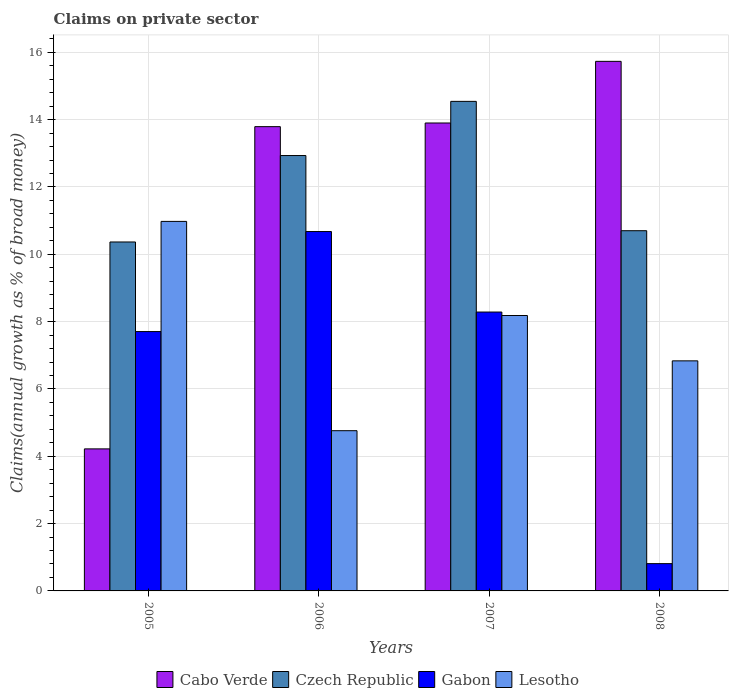How many bars are there on the 3rd tick from the left?
Offer a very short reply. 4. What is the label of the 3rd group of bars from the left?
Give a very brief answer. 2007. What is the percentage of broad money claimed on private sector in Czech Republic in 2008?
Offer a terse response. 10.7. Across all years, what is the maximum percentage of broad money claimed on private sector in Lesotho?
Keep it short and to the point. 10.98. Across all years, what is the minimum percentage of broad money claimed on private sector in Lesotho?
Ensure brevity in your answer.  4.76. What is the total percentage of broad money claimed on private sector in Cabo Verde in the graph?
Your answer should be compact. 47.64. What is the difference between the percentage of broad money claimed on private sector in Gabon in 2006 and that in 2007?
Provide a succinct answer. 2.39. What is the difference between the percentage of broad money claimed on private sector in Gabon in 2008 and the percentage of broad money claimed on private sector in Cabo Verde in 2006?
Your answer should be compact. -12.98. What is the average percentage of broad money claimed on private sector in Lesotho per year?
Offer a very short reply. 7.69. In the year 2005, what is the difference between the percentage of broad money claimed on private sector in Cabo Verde and percentage of broad money claimed on private sector in Lesotho?
Ensure brevity in your answer.  -6.76. What is the ratio of the percentage of broad money claimed on private sector in Czech Republic in 2005 to that in 2008?
Provide a short and direct response. 0.97. Is the percentage of broad money claimed on private sector in Czech Republic in 2005 less than that in 2007?
Your answer should be compact. Yes. What is the difference between the highest and the second highest percentage of broad money claimed on private sector in Cabo Verde?
Make the answer very short. 1.83. What is the difference between the highest and the lowest percentage of broad money claimed on private sector in Cabo Verde?
Make the answer very short. 11.51. In how many years, is the percentage of broad money claimed on private sector in Lesotho greater than the average percentage of broad money claimed on private sector in Lesotho taken over all years?
Give a very brief answer. 2. Is it the case that in every year, the sum of the percentage of broad money claimed on private sector in Czech Republic and percentage of broad money claimed on private sector in Cabo Verde is greater than the sum of percentage of broad money claimed on private sector in Gabon and percentage of broad money claimed on private sector in Lesotho?
Offer a terse response. Yes. What does the 4th bar from the left in 2005 represents?
Offer a terse response. Lesotho. What does the 2nd bar from the right in 2005 represents?
Keep it short and to the point. Gabon. How many years are there in the graph?
Your answer should be compact. 4. Does the graph contain any zero values?
Offer a terse response. No. What is the title of the graph?
Your answer should be compact. Claims on private sector. Does "Libya" appear as one of the legend labels in the graph?
Provide a succinct answer. No. What is the label or title of the Y-axis?
Your response must be concise. Claims(annual growth as % of broad money). What is the Claims(annual growth as % of broad money) in Cabo Verde in 2005?
Keep it short and to the point. 4.22. What is the Claims(annual growth as % of broad money) in Czech Republic in 2005?
Ensure brevity in your answer.  10.37. What is the Claims(annual growth as % of broad money) of Gabon in 2005?
Your answer should be compact. 7.7. What is the Claims(annual growth as % of broad money) in Lesotho in 2005?
Ensure brevity in your answer.  10.98. What is the Claims(annual growth as % of broad money) in Cabo Verde in 2006?
Offer a terse response. 13.79. What is the Claims(annual growth as % of broad money) of Czech Republic in 2006?
Your answer should be very brief. 12.93. What is the Claims(annual growth as % of broad money) in Gabon in 2006?
Ensure brevity in your answer.  10.68. What is the Claims(annual growth as % of broad money) in Lesotho in 2006?
Provide a succinct answer. 4.76. What is the Claims(annual growth as % of broad money) of Cabo Verde in 2007?
Give a very brief answer. 13.9. What is the Claims(annual growth as % of broad money) in Czech Republic in 2007?
Provide a short and direct response. 14.54. What is the Claims(annual growth as % of broad money) in Gabon in 2007?
Offer a terse response. 8.28. What is the Claims(annual growth as % of broad money) in Lesotho in 2007?
Your response must be concise. 8.18. What is the Claims(annual growth as % of broad money) of Cabo Verde in 2008?
Make the answer very short. 15.73. What is the Claims(annual growth as % of broad money) of Czech Republic in 2008?
Make the answer very short. 10.7. What is the Claims(annual growth as % of broad money) of Gabon in 2008?
Offer a very short reply. 0.81. What is the Claims(annual growth as % of broad money) in Lesotho in 2008?
Provide a short and direct response. 6.83. Across all years, what is the maximum Claims(annual growth as % of broad money) in Cabo Verde?
Provide a succinct answer. 15.73. Across all years, what is the maximum Claims(annual growth as % of broad money) of Czech Republic?
Make the answer very short. 14.54. Across all years, what is the maximum Claims(annual growth as % of broad money) of Gabon?
Make the answer very short. 10.68. Across all years, what is the maximum Claims(annual growth as % of broad money) of Lesotho?
Your response must be concise. 10.98. Across all years, what is the minimum Claims(annual growth as % of broad money) in Cabo Verde?
Provide a short and direct response. 4.22. Across all years, what is the minimum Claims(annual growth as % of broad money) of Czech Republic?
Give a very brief answer. 10.37. Across all years, what is the minimum Claims(annual growth as % of broad money) in Gabon?
Ensure brevity in your answer.  0.81. Across all years, what is the minimum Claims(annual growth as % of broad money) of Lesotho?
Provide a succinct answer. 4.76. What is the total Claims(annual growth as % of broad money) in Cabo Verde in the graph?
Your response must be concise. 47.64. What is the total Claims(annual growth as % of broad money) of Czech Republic in the graph?
Offer a terse response. 48.54. What is the total Claims(annual growth as % of broad money) in Gabon in the graph?
Provide a short and direct response. 27.47. What is the total Claims(annual growth as % of broad money) in Lesotho in the graph?
Make the answer very short. 30.75. What is the difference between the Claims(annual growth as % of broad money) of Cabo Verde in 2005 and that in 2006?
Offer a very short reply. -9.57. What is the difference between the Claims(annual growth as % of broad money) in Czech Republic in 2005 and that in 2006?
Give a very brief answer. -2.57. What is the difference between the Claims(annual growth as % of broad money) of Gabon in 2005 and that in 2006?
Give a very brief answer. -2.97. What is the difference between the Claims(annual growth as % of broad money) in Lesotho in 2005 and that in 2006?
Make the answer very short. 6.22. What is the difference between the Claims(annual growth as % of broad money) in Cabo Verde in 2005 and that in 2007?
Your response must be concise. -9.68. What is the difference between the Claims(annual growth as % of broad money) of Czech Republic in 2005 and that in 2007?
Give a very brief answer. -4.18. What is the difference between the Claims(annual growth as % of broad money) of Gabon in 2005 and that in 2007?
Your answer should be very brief. -0.58. What is the difference between the Claims(annual growth as % of broad money) in Lesotho in 2005 and that in 2007?
Your answer should be compact. 2.8. What is the difference between the Claims(annual growth as % of broad money) of Cabo Verde in 2005 and that in 2008?
Make the answer very short. -11.51. What is the difference between the Claims(annual growth as % of broad money) in Czech Republic in 2005 and that in 2008?
Provide a short and direct response. -0.33. What is the difference between the Claims(annual growth as % of broad money) in Gabon in 2005 and that in 2008?
Provide a succinct answer. 6.89. What is the difference between the Claims(annual growth as % of broad money) in Lesotho in 2005 and that in 2008?
Your response must be concise. 4.14. What is the difference between the Claims(annual growth as % of broad money) of Cabo Verde in 2006 and that in 2007?
Provide a succinct answer. -0.11. What is the difference between the Claims(annual growth as % of broad money) of Czech Republic in 2006 and that in 2007?
Your answer should be very brief. -1.61. What is the difference between the Claims(annual growth as % of broad money) in Gabon in 2006 and that in 2007?
Give a very brief answer. 2.39. What is the difference between the Claims(annual growth as % of broad money) of Lesotho in 2006 and that in 2007?
Provide a short and direct response. -3.42. What is the difference between the Claims(annual growth as % of broad money) in Cabo Verde in 2006 and that in 2008?
Make the answer very short. -1.94. What is the difference between the Claims(annual growth as % of broad money) in Czech Republic in 2006 and that in 2008?
Your answer should be compact. 2.23. What is the difference between the Claims(annual growth as % of broad money) of Gabon in 2006 and that in 2008?
Your answer should be compact. 9.86. What is the difference between the Claims(annual growth as % of broad money) of Lesotho in 2006 and that in 2008?
Your response must be concise. -2.07. What is the difference between the Claims(annual growth as % of broad money) of Cabo Verde in 2007 and that in 2008?
Keep it short and to the point. -1.83. What is the difference between the Claims(annual growth as % of broad money) of Czech Republic in 2007 and that in 2008?
Your answer should be compact. 3.84. What is the difference between the Claims(annual growth as % of broad money) of Gabon in 2007 and that in 2008?
Ensure brevity in your answer.  7.47. What is the difference between the Claims(annual growth as % of broad money) in Lesotho in 2007 and that in 2008?
Ensure brevity in your answer.  1.35. What is the difference between the Claims(annual growth as % of broad money) of Cabo Verde in 2005 and the Claims(annual growth as % of broad money) of Czech Republic in 2006?
Provide a short and direct response. -8.71. What is the difference between the Claims(annual growth as % of broad money) of Cabo Verde in 2005 and the Claims(annual growth as % of broad money) of Gabon in 2006?
Offer a very short reply. -6.46. What is the difference between the Claims(annual growth as % of broad money) of Cabo Verde in 2005 and the Claims(annual growth as % of broad money) of Lesotho in 2006?
Offer a very short reply. -0.54. What is the difference between the Claims(annual growth as % of broad money) of Czech Republic in 2005 and the Claims(annual growth as % of broad money) of Gabon in 2006?
Provide a succinct answer. -0.31. What is the difference between the Claims(annual growth as % of broad money) in Czech Republic in 2005 and the Claims(annual growth as % of broad money) in Lesotho in 2006?
Keep it short and to the point. 5.61. What is the difference between the Claims(annual growth as % of broad money) in Gabon in 2005 and the Claims(annual growth as % of broad money) in Lesotho in 2006?
Keep it short and to the point. 2.94. What is the difference between the Claims(annual growth as % of broad money) in Cabo Verde in 2005 and the Claims(annual growth as % of broad money) in Czech Republic in 2007?
Make the answer very short. -10.32. What is the difference between the Claims(annual growth as % of broad money) of Cabo Verde in 2005 and the Claims(annual growth as % of broad money) of Gabon in 2007?
Your answer should be very brief. -4.06. What is the difference between the Claims(annual growth as % of broad money) in Cabo Verde in 2005 and the Claims(annual growth as % of broad money) in Lesotho in 2007?
Your answer should be compact. -3.96. What is the difference between the Claims(annual growth as % of broad money) of Czech Republic in 2005 and the Claims(annual growth as % of broad money) of Gabon in 2007?
Ensure brevity in your answer.  2.08. What is the difference between the Claims(annual growth as % of broad money) in Czech Republic in 2005 and the Claims(annual growth as % of broad money) in Lesotho in 2007?
Ensure brevity in your answer.  2.18. What is the difference between the Claims(annual growth as % of broad money) in Gabon in 2005 and the Claims(annual growth as % of broad money) in Lesotho in 2007?
Offer a very short reply. -0.48. What is the difference between the Claims(annual growth as % of broad money) in Cabo Verde in 2005 and the Claims(annual growth as % of broad money) in Czech Republic in 2008?
Your answer should be very brief. -6.48. What is the difference between the Claims(annual growth as % of broad money) of Cabo Verde in 2005 and the Claims(annual growth as % of broad money) of Gabon in 2008?
Give a very brief answer. 3.41. What is the difference between the Claims(annual growth as % of broad money) of Cabo Verde in 2005 and the Claims(annual growth as % of broad money) of Lesotho in 2008?
Your response must be concise. -2.61. What is the difference between the Claims(annual growth as % of broad money) of Czech Republic in 2005 and the Claims(annual growth as % of broad money) of Gabon in 2008?
Ensure brevity in your answer.  9.55. What is the difference between the Claims(annual growth as % of broad money) of Czech Republic in 2005 and the Claims(annual growth as % of broad money) of Lesotho in 2008?
Offer a terse response. 3.53. What is the difference between the Claims(annual growth as % of broad money) of Gabon in 2005 and the Claims(annual growth as % of broad money) of Lesotho in 2008?
Offer a very short reply. 0.87. What is the difference between the Claims(annual growth as % of broad money) of Cabo Verde in 2006 and the Claims(annual growth as % of broad money) of Czech Republic in 2007?
Offer a terse response. -0.75. What is the difference between the Claims(annual growth as % of broad money) in Cabo Verde in 2006 and the Claims(annual growth as % of broad money) in Gabon in 2007?
Provide a succinct answer. 5.51. What is the difference between the Claims(annual growth as % of broad money) of Cabo Verde in 2006 and the Claims(annual growth as % of broad money) of Lesotho in 2007?
Keep it short and to the point. 5.61. What is the difference between the Claims(annual growth as % of broad money) of Czech Republic in 2006 and the Claims(annual growth as % of broad money) of Gabon in 2007?
Your response must be concise. 4.65. What is the difference between the Claims(annual growth as % of broad money) of Czech Republic in 2006 and the Claims(annual growth as % of broad money) of Lesotho in 2007?
Your answer should be compact. 4.75. What is the difference between the Claims(annual growth as % of broad money) of Gabon in 2006 and the Claims(annual growth as % of broad money) of Lesotho in 2007?
Provide a succinct answer. 2.49. What is the difference between the Claims(annual growth as % of broad money) of Cabo Verde in 2006 and the Claims(annual growth as % of broad money) of Czech Republic in 2008?
Your answer should be very brief. 3.09. What is the difference between the Claims(annual growth as % of broad money) of Cabo Verde in 2006 and the Claims(annual growth as % of broad money) of Gabon in 2008?
Your answer should be compact. 12.98. What is the difference between the Claims(annual growth as % of broad money) of Cabo Verde in 2006 and the Claims(annual growth as % of broad money) of Lesotho in 2008?
Your answer should be compact. 6.96. What is the difference between the Claims(annual growth as % of broad money) of Czech Republic in 2006 and the Claims(annual growth as % of broad money) of Gabon in 2008?
Your response must be concise. 12.12. What is the difference between the Claims(annual growth as % of broad money) in Czech Republic in 2006 and the Claims(annual growth as % of broad money) in Lesotho in 2008?
Your answer should be very brief. 6.1. What is the difference between the Claims(annual growth as % of broad money) in Gabon in 2006 and the Claims(annual growth as % of broad money) in Lesotho in 2008?
Make the answer very short. 3.84. What is the difference between the Claims(annual growth as % of broad money) of Cabo Verde in 2007 and the Claims(annual growth as % of broad money) of Czech Republic in 2008?
Your answer should be compact. 3.2. What is the difference between the Claims(annual growth as % of broad money) in Cabo Verde in 2007 and the Claims(annual growth as % of broad money) in Gabon in 2008?
Your response must be concise. 13.09. What is the difference between the Claims(annual growth as % of broad money) in Cabo Verde in 2007 and the Claims(annual growth as % of broad money) in Lesotho in 2008?
Offer a very short reply. 7.07. What is the difference between the Claims(annual growth as % of broad money) of Czech Republic in 2007 and the Claims(annual growth as % of broad money) of Gabon in 2008?
Your answer should be compact. 13.73. What is the difference between the Claims(annual growth as % of broad money) of Czech Republic in 2007 and the Claims(annual growth as % of broad money) of Lesotho in 2008?
Your response must be concise. 7.71. What is the difference between the Claims(annual growth as % of broad money) of Gabon in 2007 and the Claims(annual growth as % of broad money) of Lesotho in 2008?
Your answer should be compact. 1.45. What is the average Claims(annual growth as % of broad money) in Cabo Verde per year?
Make the answer very short. 11.91. What is the average Claims(annual growth as % of broad money) in Czech Republic per year?
Give a very brief answer. 12.14. What is the average Claims(annual growth as % of broad money) of Gabon per year?
Your answer should be very brief. 6.87. What is the average Claims(annual growth as % of broad money) of Lesotho per year?
Offer a terse response. 7.69. In the year 2005, what is the difference between the Claims(annual growth as % of broad money) in Cabo Verde and Claims(annual growth as % of broad money) in Czech Republic?
Your answer should be compact. -6.15. In the year 2005, what is the difference between the Claims(annual growth as % of broad money) in Cabo Verde and Claims(annual growth as % of broad money) in Gabon?
Make the answer very short. -3.48. In the year 2005, what is the difference between the Claims(annual growth as % of broad money) in Cabo Verde and Claims(annual growth as % of broad money) in Lesotho?
Your response must be concise. -6.76. In the year 2005, what is the difference between the Claims(annual growth as % of broad money) in Czech Republic and Claims(annual growth as % of broad money) in Gabon?
Ensure brevity in your answer.  2.66. In the year 2005, what is the difference between the Claims(annual growth as % of broad money) in Czech Republic and Claims(annual growth as % of broad money) in Lesotho?
Provide a succinct answer. -0.61. In the year 2005, what is the difference between the Claims(annual growth as % of broad money) in Gabon and Claims(annual growth as % of broad money) in Lesotho?
Your answer should be very brief. -3.27. In the year 2006, what is the difference between the Claims(annual growth as % of broad money) of Cabo Verde and Claims(annual growth as % of broad money) of Czech Republic?
Keep it short and to the point. 0.86. In the year 2006, what is the difference between the Claims(annual growth as % of broad money) of Cabo Verde and Claims(annual growth as % of broad money) of Gabon?
Offer a very short reply. 3.12. In the year 2006, what is the difference between the Claims(annual growth as % of broad money) in Cabo Verde and Claims(annual growth as % of broad money) in Lesotho?
Make the answer very short. 9.03. In the year 2006, what is the difference between the Claims(annual growth as % of broad money) in Czech Republic and Claims(annual growth as % of broad money) in Gabon?
Your answer should be very brief. 2.26. In the year 2006, what is the difference between the Claims(annual growth as % of broad money) in Czech Republic and Claims(annual growth as % of broad money) in Lesotho?
Offer a very short reply. 8.17. In the year 2006, what is the difference between the Claims(annual growth as % of broad money) in Gabon and Claims(annual growth as % of broad money) in Lesotho?
Your answer should be compact. 5.92. In the year 2007, what is the difference between the Claims(annual growth as % of broad money) in Cabo Verde and Claims(annual growth as % of broad money) in Czech Republic?
Give a very brief answer. -0.64. In the year 2007, what is the difference between the Claims(annual growth as % of broad money) in Cabo Verde and Claims(annual growth as % of broad money) in Gabon?
Keep it short and to the point. 5.62. In the year 2007, what is the difference between the Claims(annual growth as % of broad money) in Cabo Verde and Claims(annual growth as % of broad money) in Lesotho?
Ensure brevity in your answer.  5.72. In the year 2007, what is the difference between the Claims(annual growth as % of broad money) in Czech Republic and Claims(annual growth as % of broad money) in Gabon?
Provide a short and direct response. 6.26. In the year 2007, what is the difference between the Claims(annual growth as % of broad money) of Czech Republic and Claims(annual growth as % of broad money) of Lesotho?
Provide a succinct answer. 6.36. In the year 2007, what is the difference between the Claims(annual growth as % of broad money) in Gabon and Claims(annual growth as % of broad money) in Lesotho?
Make the answer very short. 0.1. In the year 2008, what is the difference between the Claims(annual growth as % of broad money) of Cabo Verde and Claims(annual growth as % of broad money) of Czech Republic?
Offer a very short reply. 5.03. In the year 2008, what is the difference between the Claims(annual growth as % of broad money) in Cabo Verde and Claims(annual growth as % of broad money) in Gabon?
Provide a short and direct response. 14.92. In the year 2008, what is the difference between the Claims(annual growth as % of broad money) in Cabo Verde and Claims(annual growth as % of broad money) in Lesotho?
Ensure brevity in your answer.  8.9. In the year 2008, what is the difference between the Claims(annual growth as % of broad money) in Czech Republic and Claims(annual growth as % of broad money) in Gabon?
Ensure brevity in your answer.  9.89. In the year 2008, what is the difference between the Claims(annual growth as % of broad money) in Czech Republic and Claims(annual growth as % of broad money) in Lesotho?
Your answer should be very brief. 3.87. In the year 2008, what is the difference between the Claims(annual growth as % of broad money) in Gabon and Claims(annual growth as % of broad money) in Lesotho?
Give a very brief answer. -6.02. What is the ratio of the Claims(annual growth as % of broad money) in Cabo Verde in 2005 to that in 2006?
Your response must be concise. 0.31. What is the ratio of the Claims(annual growth as % of broad money) of Czech Republic in 2005 to that in 2006?
Offer a very short reply. 0.8. What is the ratio of the Claims(annual growth as % of broad money) in Gabon in 2005 to that in 2006?
Your answer should be compact. 0.72. What is the ratio of the Claims(annual growth as % of broad money) of Lesotho in 2005 to that in 2006?
Your response must be concise. 2.31. What is the ratio of the Claims(annual growth as % of broad money) in Cabo Verde in 2005 to that in 2007?
Your response must be concise. 0.3. What is the ratio of the Claims(annual growth as % of broad money) in Czech Republic in 2005 to that in 2007?
Provide a succinct answer. 0.71. What is the ratio of the Claims(annual growth as % of broad money) of Gabon in 2005 to that in 2007?
Offer a very short reply. 0.93. What is the ratio of the Claims(annual growth as % of broad money) of Lesotho in 2005 to that in 2007?
Offer a very short reply. 1.34. What is the ratio of the Claims(annual growth as % of broad money) in Cabo Verde in 2005 to that in 2008?
Your response must be concise. 0.27. What is the ratio of the Claims(annual growth as % of broad money) of Czech Republic in 2005 to that in 2008?
Your answer should be very brief. 0.97. What is the ratio of the Claims(annual growth as % of broad money) in Gabon in 2005 to that in 2008?
Offer a terse response. 9.5. What is the ratio of the Claims(annual growth as % of broad money) of Lesotho in 2005 to that in 2008?
Your answer should be compact. 1.61. What is the ratio of the Claims(annual growth as % of broad money) in Czech Republic in 2006 to that in 2007?
Offer a terse response. 0.89. What is the ratio of the Claims(annual growth as % of broad money) in Gabon in 2006 to that in 2007?
Ensure brevity in your answer.  1.29. What is the ratio of the Claims(annual growth as % of broad money) in Lesotho in 2006 to that in 2007?
Provide a short and direct response. 0.58. What is the ratio of the Claims(annual growth as % of broad money) in Cabo Verde in 2006 to that in 2008?
Offer a terse response. 0.88. What is the ratio of the Claims(annual growth as % of broad money) in Czech Republic in 2006 to that in 2008?
Make the answer very short. 1.21. What is the ratio of the Claims(annual growth as % of broad money) in Gabon in 2006 to that in 2008?
Provide a short and direct response. 13.17. What is the ratio of the Claims(annual growth as % of broad money) in Lesotho in 2006 to that in 2008?
Provide a short and direct response. 0.7. What is the ratio of the Claims(annual growth as % of broad money) of Cabo Verde in 2007 to that in 2008?
Make the answer very short. 0.88. What is the ratio of the Claims(annual growth as % of broad money) in Czech Republic in 2007 to that in 2008?
Your response must be concise. 1.36. What is the ratio of the Claims(annual growth as % of broad money) in Gabon in 2007 to that in 2008?
Offer a very short reply. 10.22. What is the ratio of the Claims(annual growth as % of broad money) of Lesotho in 2007 to that in 2008?
Ensure brevity in your answer.  1.2. What is the difference between the highest and the second highest Claims(annual growth as % of broad money) of Cabo Verde?
Your response must be concise. 1.83. What is the difference between the highest and the second highest Claims(annual growth as % of broad money) in Czech Republic?
Offer a very short reply. 1.61. What is the difference between the highest and the second highest Claims(annual growth as % of broad money) of Gabon?
Provide a short and direct response. 2.39. What is the difference between the highest and the second highest Claims(annual growth as % of broad money) of Lesotho?
Give a very brief answer. 2.8. What is the difference between the highest and the lowest Claims(annual growth as % of broad money) of Cabo Verde?
Offer a very short reply. 11.51. What is the difference between the highest and the lowest Claims(annual growth as % of broad money) in Czech Republic?
Your answer should be compact. 4.18. What is the difference between the highest and the lowest Claims(annual growth as % of broad money) in Gabon?
Provide a succinct answer. 9.86. What is the difference between the highest and the lowest Claims(annual growth as % of broad money) of Lesotho?
Your response must be concise. 6.22. 